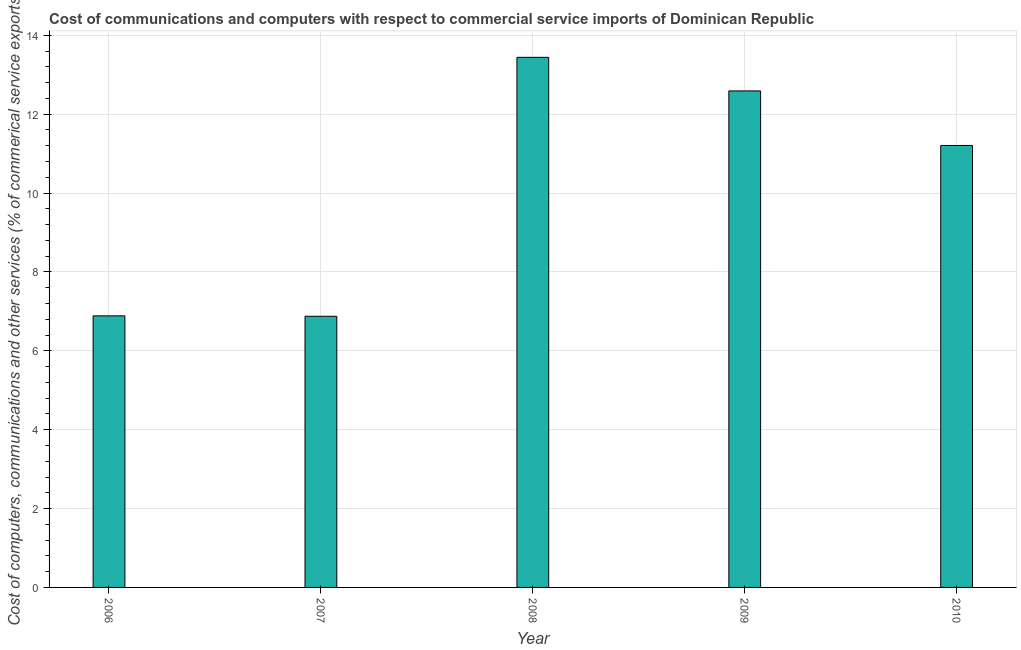What is the title of the graph?
Provide a succinct answer. Cost of communications and computers with respect to commercial service imports of Dominican Republic. What is the label or title of the X-axis?
Your answer should be compact. Year. What is the label or title of the Y-axis?
Make the answer very short. Cost of computers, communications and other services (% of commerical service exports). What is the cost of communications in 2010?
Make the answer very short. 11.21. Across all years, what is the maximum  computer and other services?
Provide a short and direct response. 13.44. Across all years, what is the minimum  computer and other services?
Offer a terse response. 6.88. What is the sum of the cost of communications?
Make the answer very short. 51. What is the difference between the cost of communications in 2009 and 2010?
Offer a very short reply. 1.38. What is the median cost of communications?
Provide a short and direct response. 11.21. What is the ratio of the  computer and other services in 2006 to that in 2007?
Provide a short and direct response. 1. Is the difference between the cost of communications in 2008 and 2009 greater than the difference between any two years?
Offer a terse response. No. What is the difference between the highest and the second highest cost of communications?
Give a very brief answer. 0.85. What is the difference between the highest and the lowest cost of communications?
Give a very brief answer. 6.57. In how many years, is the cost of communications greater than the average cost of communications taken over all years?
Offer a terse response. 3. How many bars are there?
Your response must be concise. 5. What is the difference between two consecutive major ticks on the Y-axis?
Keep it short and to the point. 2. What is the Cost of computers, communications and other services (% of commerical service exports) of 2006?
Offer a very short reply. 6.89. What is the Cost of computers, communications and other services (% of commerical service exports) of 2007?
Ensure brevity in your answer.  6.88. What is the Cost of computers, communications and other services (% of commerical service exports) of 2008?
Keep it short and to the point. 13.44. What is the Cost of computers, communications and other services (% of commerical service exports) of 2009?
Keep it short and to the point. 12.59. What is the Cost of computers, communications and other services (% of commerical service exports) in 2010?
Provide a short and direct response. 11.21. What is the difference between the Cost of computers, communications and other services (% of commerical service exports) in 2006 and 2007?
Your response must be concise. 0.01. What is the difference between the Cost of computers, communications and other services (% of commerical service exports) in 2006 and 2008?
Offer a terse response. -6.56. What is the difference between the Cost of computers, communications and other services (% of commerical service exports) in 2006 and 2009?
Give a very brief answer. -5.7. What is the difference between the Cost of computers, communications and other services (% of commerical service exports) in 2006 and 2010?
Ensure brevity in your answer.  -4.32. What is the difference between the Cost of computers, communications and other services (% of commerical service exports) in 2007 and 2008?
Offer a terse response. -6.57. What is the difference between the Cost of computers, communications and other services (% of commerical service exports) in 2007 and 2009?
Your response must be concise. -5.71. What is the difference between the Cost of computers, communications and other services (% of commerical service exports) in 2007 and 2010?
Keep it short and to the point. -4.33. What is the difference between the Cost of computers, communications and other services (% of commerical service exports) in 2008 and 2009?
Provide a short and direct response. 0.85. What is the difference between the Cost of computers, communications and other services (% of commerical service exports) in 2008 and 2010?
Make the answer very short. 2.24. What is the difference between the Cost of computers, communications and other services (% of commerical service exports) in 2009 and 2010?
Offer a very short reply. 1.38. What is the ratio of the Cost of computers, communications and other services (% of commerical service exports) in 2006 to that in 2007?
Offer a terse response. 1. What is the ratio of the Cost of computers, communications and other services (% of commerical service exports) in 2006 to that in 2008?
Provide a succinct answer. 0.51. What is the ratio of the Cost of computers, communications and other services (% of commerical service exports) in 2006 to that in 2009?
Your response must be concise. 0.55. What is the ratio of the Cost of computers, communications and other services (% of commerical service exports) in 2006 to that in 2010?
Provide a succinct answer. 0.61. What is the ratio of the Cost of computers, communications and other services (% of commerical service exports) in 2007 to that in 2008?
Provide a succinct answer. 0.51. What is the ratio of the Cost of computers, communications and other services (% of commerical service exports) in 2007 to that in 2009?
Offer a very short reply. 0.55. What is the ratio of the Cost of computers, communications and other services (% of commerical service exports) in 2007 to that in 2010?
Provide a short and direct response. 0.61. What is the ratio of the Cost of computers, communications and other services (% of commerical service exports) in 2008 to that in 2009?
Ensure brevity in your answer.  1.07. What is the ratio of the Cost of computers, communications and other services (% of commerical service exports) in 2008 to that in 2010?
Make the answer very short. 1.2. What is the ratio of the Cost of computers, communications and other services (% of commerical service exports) in 2009 to that in 2010?
Provide a short and direct response. 1.12. 